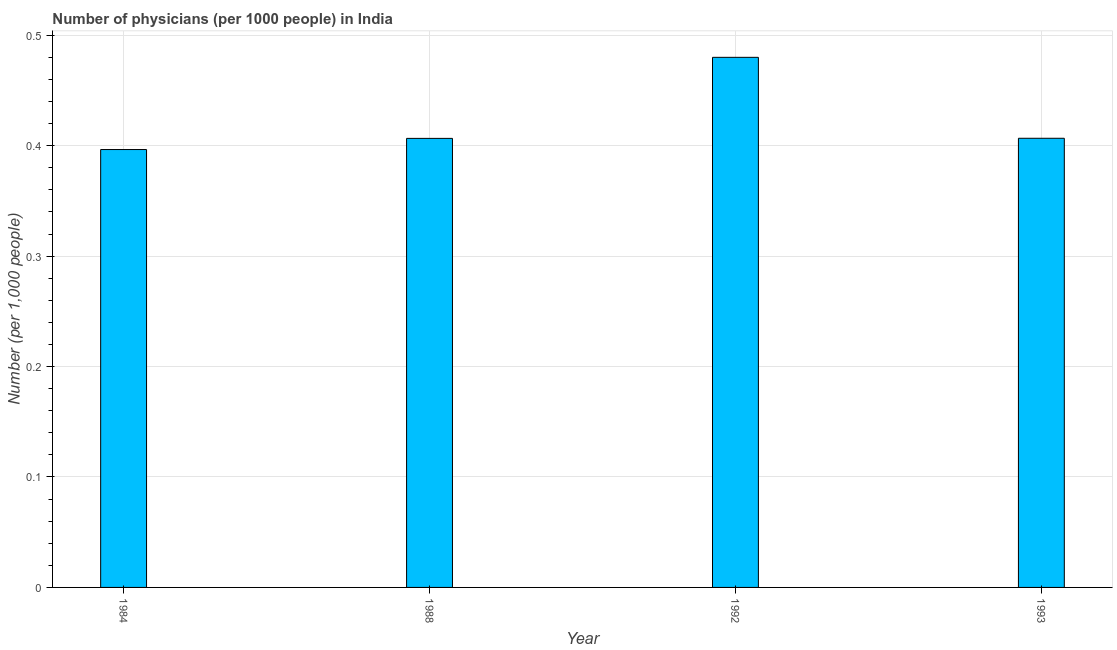Does the graph contain any zero values?
Offer a terse response. No. Does the graph contain grids?
Provide a short and direct response. Yes. What is the title of the graph?
Your response must be concise. Number of physicians (per 1000 people) in India. What is the label or title of the X-axis?
Offer a terse response. Year. What is the label or title of the Y-axis?
Your response must be concise. Number (per 1,0 people). What is the number of physicians in 1984?
Ensure brevity in your answer.  0.4. Across all years, what is the maximum number of physicians?
Offer a very short reply. 0.48. Across all years, what is the minimum number of physicians?
Your response must be concise. 0.4. In which year was the number of physicians maximum?
Offer a very short reply. 1992. What is the sum of the number of physicians?
Your answer should be compact. 1.69. What is the difference between the number of physicians in 1988 and 1993?
Offer a terse response. -0. What is the average number of physicians per year?
Give a very brief answer. 0.42. What is the median number of physicians?
Give a very brief answer. 0.41. Do a majority of the years between 1993 and 1988 (inclusive) have number of physicians greater than 0.18 ?
Offer a terse response. Yes. What is the ratio of the number of physicians in 1984 to that in 1992?
Ensure brevity in your answer.  0.83. Is the number of physicians in 1984 less than that in 1993?
Your answer should be very brief. Yes. What is the difference between the highest and the second highest number of physicians?
Provide a succinct answer. 0.07. How many bars are there?
Offer a terse response. 4. How many years are there in the graph?
Make the answer very short. 4. What is the difference between two consecutive major ticks on the Y-axis?
Give a very brief answer. 0.1. What is the Number (per 1,000 people) in 1984?
Offer a very short reply. 0.4. What is the Number (per 1,000 people) in 1988?
Make the answer very short. 0.41. What is the Number (per 1,000 people) of 1992?
Keep it short and to the point. 0.48. What is the Number (per 1,000 people) of 1993?
Keep it short and to the point. 0.41. What is the difference between the Number (per 1,000 people) in 1984 and 1988?
Make the answer very short. -0.01. What is the difference between the Number (per 1,000 people) in 1984 and 1992?
Ensure brevity in your answer.  -0.08. What is the difference between the Number (per 1,000 people) in 1984 and 1993?
Offer a terse response. -0.01. What is the difference between the Number (per 1,000 people) in 1988 and 1992?
Offer a very short reply. -0.07. What is the difference between the Number (per 1,000 people) in 1988 and 1993?
Give a very brief answer. -0. What is the difference between the Number (per 1,000 people) in 1992 and 1993?
Make the answer very short. 0.07. What is the ratio of the Number (per 1,000 people) in 1984 to that in 1988?
Ensure brevity in your answer.  0.97. What is the ratio of the Number (per 1,000 people) in 1984 to that in 1992?
Your answer should be compact. 0.83. What is the ratio of the Number (per 1,000 people) in 1984 to that in 1993?
Offer a terse response. 0.97. What is the ratio of the Number (per 1,000 people) in 1988 to that in 1992?
Give a very brief answer. 0.85. What is the ratio of the Number (per 1,000 people) in 1988 to that in 1993?
Make the answer very short. 1. What is the ratio of the Number (per 1,000 people) in 1992 to that in 1993?
Your answer should be compact. 1.18. 